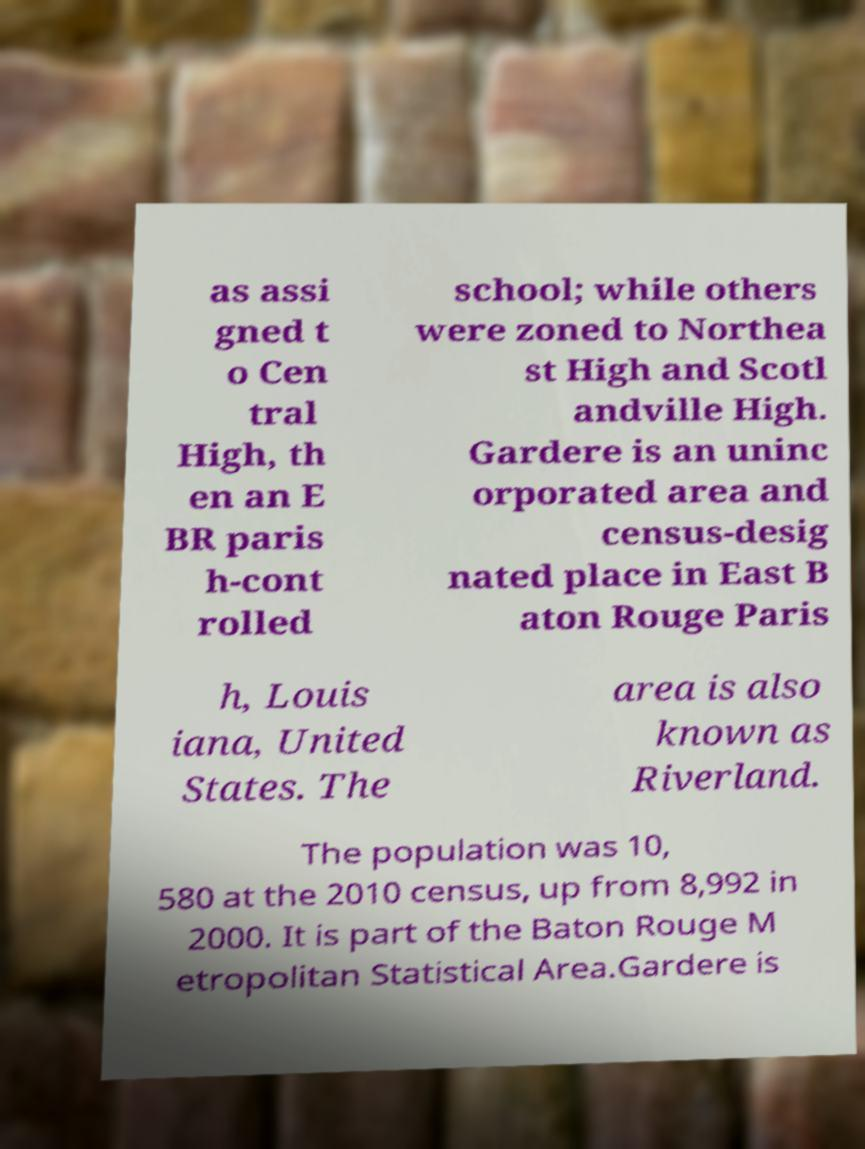Can you accurately transcribe the text from the provided image for me? as assi gned t o Cen tral High, th en an E BR paris h-cont rolled school; while others were zoned to Northea st High and Scotl andville High. Gardere is an uninc orporated area and census-desig nated place in East B aton Rouge Paris h, Louis iana, United States. The area is also known as Riverland. The population was 10, 580 at the 2010 census, up from 8,992 in 2000. It is part of the Baton Rouge M etropolitan Statistical Area.Gardere is 